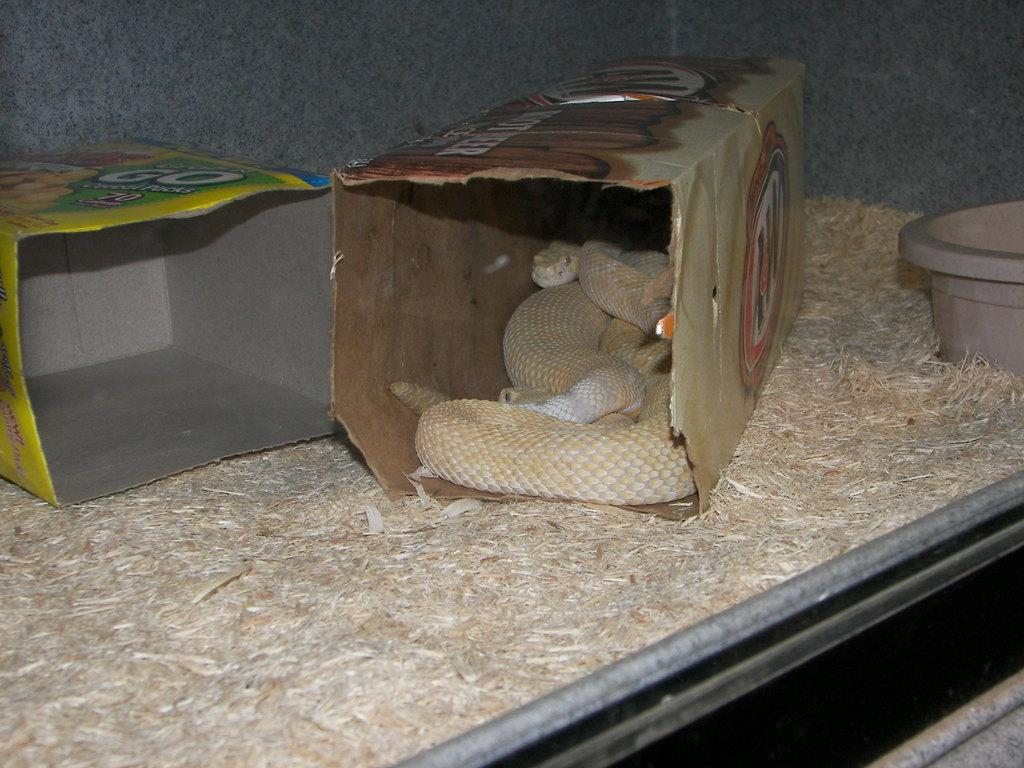What animal is present in the image? There is a snake in the image. Where is the snake located? The snake is in a box. What type of vegetation can be seen in the image? There is dried grass in the image. What type of pencil can be seen in the image? There is no pencil present in the image. 